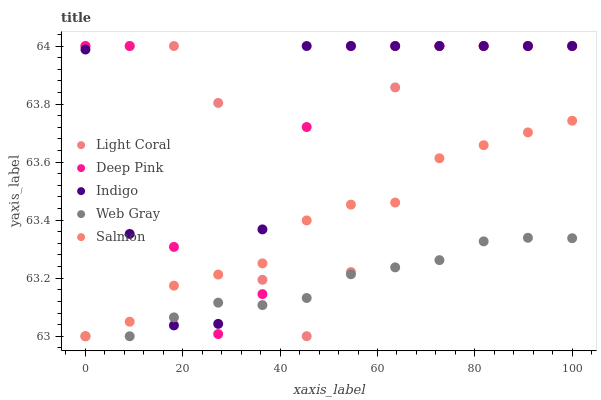Does Web Gray have the minimum area under the curve?
Answer yes or no. Yes. Does Deep Pink have the maximum area under the curve?
Answer yes or no. Yes. Does Salmon have the minimum area under the curve?
Answer yes or no. No. Does Salmon have the maximum area under the curve?
Answer yes or no. No. Is Web Gray the smoothest?
Answer yes or no. Yes. Is Deep Pink the roughest?
Answer yes or no. Yes. Is Salmon the smoothest?
Answer yes or no. No. Is Salmon the roughest?
Answer yes or no. No. Does Salmon have the lowest value?
Answer yes or no. Yes. Does Deep Pink have the lowest value?
Answer yes or no. No. Does Indigo have the highest value?
Answer yes or no. Yes. Does Salmon have the highest value?
Answer yes or no. No. Does Salmon intersect Deep Pink?
Answer yes or no. Yes. Is Salmon less than Deep Pink?
Answer yes or no. No. Is Salmon greater than Deep Pink?
Answer yes or no. No. 